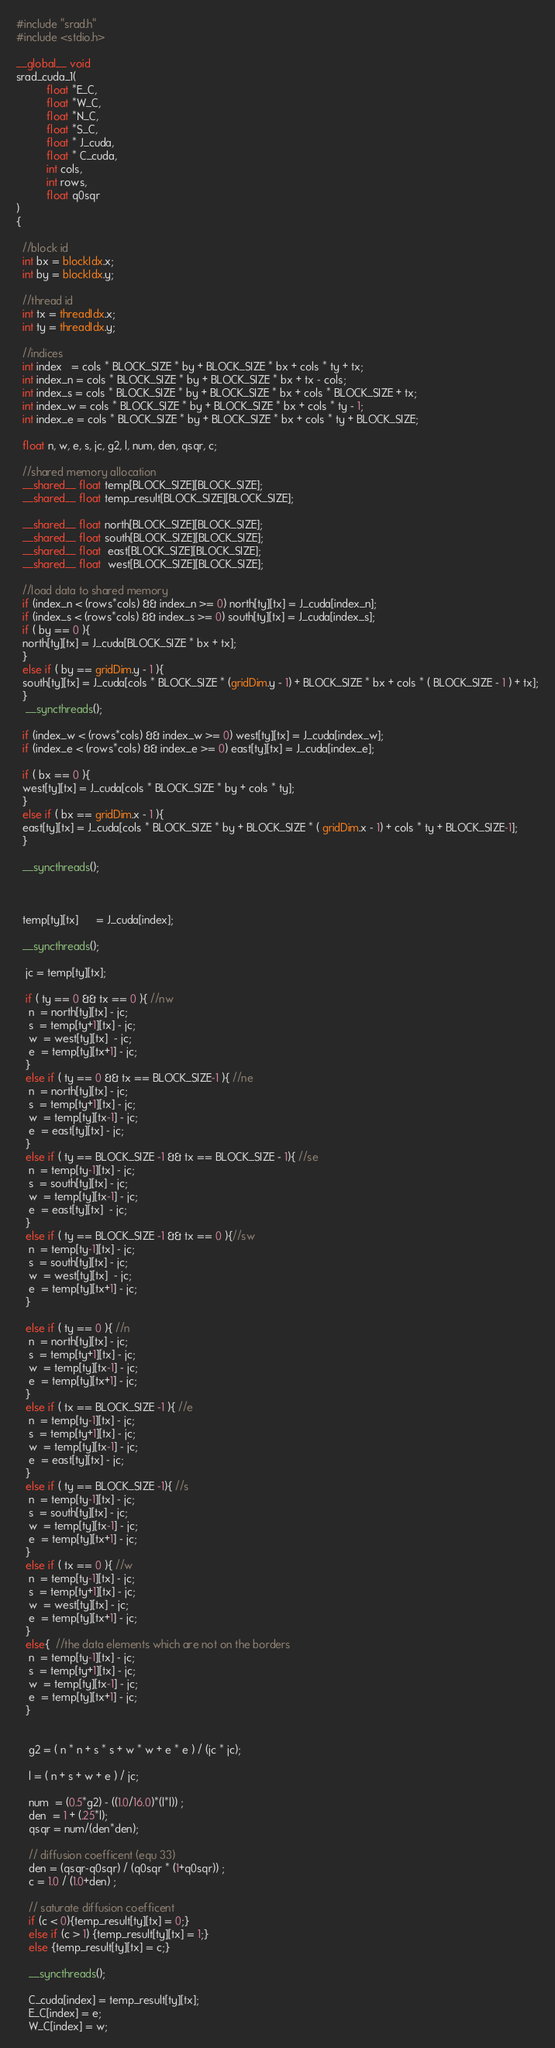<code> <loc_0><loc_0><loc_500><loc_500><_Cuda_>#include "srad.h"
#include <stdio.h>

__global__ void
srad_cuda_1(
		  float *E_C, 
		  float *W_C, 
		  float *N_C, 
		  float *S_C,
		  float * J_cuda, 
		  float * C_cuda, 
		  int cols, 
		  int rows, 
		  float q0sqr
) 
{

  //block id
  int bx = blockIdx.x;
  int by = blockIdx.y;

  //thread id
  int tx = threadIdx.x;
  int ty = threadIdx.y;
  
  //indices
  int index   = cols * BLOCK_SIZE * by + BLOCK_SIZE * bx + cols * ty + tx;
  int index_n = cols * BLOCK_SIZE * by + BLOCK_SIZE * bx + tx - cols;
  int index_s = cols * BLOCK_SIZE * by + BLOCK_SIZE * bx + cols * BLOCK_SIZE + tx;
  int index_w = cols * BLOCK_SIZE * by + BLOCK_SIZE * bx + cols * ty - 1;
  int index_e = cols * BLOCK_SIZE * by + BLOCK_SIZE * bx + cols * ty + BLOCK_SIZE;

  float n, w, e, s, jc, g2, l, num, den, qsqr, c;

  //shared memory allocation
  __shared__ float temp[BLOCK_SIZE][BLOCK_SIZE];
  __shared__ float temp_result[BLOCK_SIZE][BLOCK_SIZE];

  __shared__ float north[BLOCK_SIZE][BLOCK_SIZE];
  __shared__ float south[BLOCK_SIZE][BLOCK_SIZE];
  __shared__ float  east[BLOCK_SIZE][BLOCK_SIZE];
  __shared__ float  west[BLOCK_SIZE][BLOCK_SIZE];

  //load data to shared memory
  if (index_n < (rows*cols) && index_n >= 0) north[ty][tx] = J_cuda[index_n]; 
  if (index_s < (rows*cols) && index_s >= 0) south[ty][tx] = J_cuda[index_s];
  if ( by == 0 ){
  north[ty][tx] = J_cuda[BLOCK_SIZE * bx + tx]; 
  }
  else if ( by == gridDim.y - 1 ){
  south[ty][tx] = J_cuda[cols * BLOCK_SIZE * (gridDim.y - 1) + BLOCK_SIZE * bx + cols * ( BLOCK_SIZE - 1 ) + tx];
  }
   __syncthreads();
 
  if (index_w < (rows*cols) && index_w >= 0) west[ty][tx] = J_cuda[index_w];
  if (index_e < (rows*cols) && index_e >= 0) east[ty][tx] = J_cuda[index_e];

  if ( bx == 0 ){
  west[ty][tx] = J_cuda[cols * BLOCK_SIZE * by + cols * ty]; 
  }
  else if ( bx == gridDim.x - 1 ){
  east[ty][tx] = J_cuda[cols * BLOCK_SIZE * by + BLOCK_SIZE * ( gridDim.x - 1) + cols * ty + BLOCK_SIZE-1];
  }
 
  __syncthreads();
  
 

  temp[ty][tx]      = J_cuda[index];

  __syncthreads();

   jc = temp[ty][tx];

   if ( ty == 0 && tx == 0 ){ //nw
	n  = north[ty][tx] - jc;
    s  = temp[ty+1][tx] - jc;
    w  = west[ty][tx]  - jc; 
    e  = temp[ty][tx+1] - jc;
   }	    
   else if ( ty == 0 && tx == BLOCK_SIZE-1 ){ //ne
	n  = north[ty][tx] - jc;
    s  = temp[ty+1][tx] - jc;
    w  = temp[ty][tx-1] - jc; 
    e  = east[ty][tx] - jc;
   }
   else if ( ty == BLOCK_SIZE -1 && tx == BLOCK_SIZE - 1){ //se
	n  = temp[ty-1][tx] - jc;
    s  = south[ty][tx] - jc;
    w  = temp[ty][tx-1] - jc; 
    e  = east[ty][tx]  - jc;
   }
   else if ( ty == BLOCK_SIZE -1 && tx == 0 ){//sw
	n  = temp[ty-1][tx] - jc;
    s  = south[ty][tx] - jc;
    w  = west[ty][tx]  - jc; 
    e  = temp[ty][tx+1] - jc;
   }

   else if ( ty == 0 ){ //n
	n  = north[ty][tx] - jc;
    s  = temp[ty+1][tx] - jc;
    w  = temp[ty][tx-1] - jc; 
    e  = temp[ty][tx+1] - jc;
   }
   else if ( tx == BLOCK_SIZE -1 ){ //e
	n  = temp[ty-1][tx] - jc;
    s  = temp[ty+1][tx] - jc;
    w  = temp[ty][tx-1] - jc; 
    e  = east[ty][tx] - jc;
   }
   else if ( ty == BLOCK_SIZE -1){ //s
	n  = temp[ty-1][tx] - jc;
    s  = south[ty][tx] - jc;
    w  = temp[ty][tx-1] - jc; 
    e  = temp[ty][tx+1] - jc;
   }
   else if ( tx == 0 ){ //w
	n  = temp[ty-1][tx] - jc;
    s  = temp[ty+1][tx] - jc;
    w  = west[ty][tx] - jc; 
    e  = temp[ty][tx+1] - jc;
   }
   else{  //the data elements which are not on the borders 
	n  = temp[ty-1][tx] - jc;
    s  = temp[ty+1][tx] - jc;
    w  = temp[ty][tx-1] - jc; 
    e  = temp[ty][tx+1] - jc;
   }


    g2 = ( n * n + s * s + w * w + e * e ) / (jc * jc);

    l = ( n + s + w + e ) / jc;

	num  = (0.5*g2) - ((1.0/16.0)*(l*l)) ;
	den  = 1 + (.25*l);
	qsqr = num/(den*den);

	// diffusion coefficent (equ 33)
	den = (qsqr-q0sqr) / (q0sqr * (1+q0sqr)) ;
	c = 1.0 / (1.0+den) ;

    // saturate diffusion coefficent
	if (c < 0){temp_result[ty][tx] = 0;}
	else if (c > 1) {temp_result[ty][tx] = 1;}
	else {temp_result[ty][tx] = c;}

    __syncthreads();

    C_cuda[index] = temp_result[ty][tx];
	E_C[index] = e;
	W_C[index] = w;</code> 